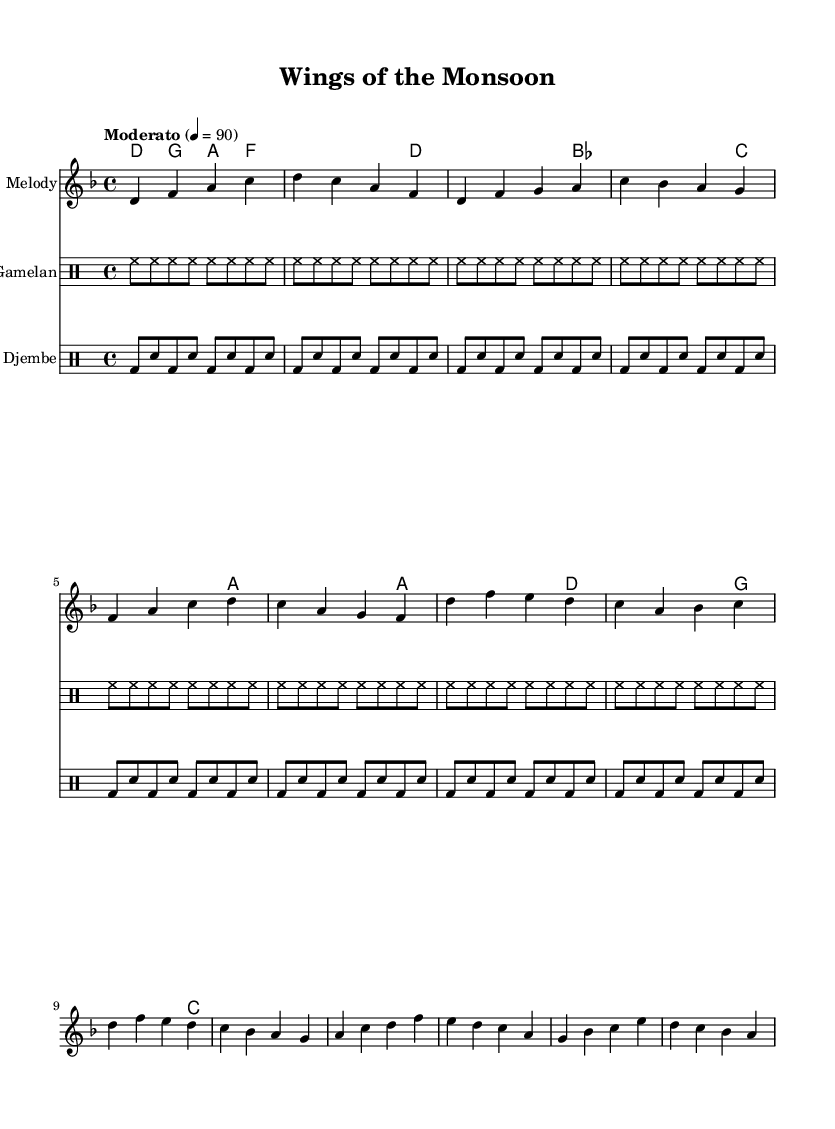What is the key signature of this music? The key signature is indicated at the beginning of the staff. It shows two flats (B♭ and E♭), which indicates the music is in D minor, as confirmed by the presence of D in the melody and harmonies.
Answer: D minor What is the time signature of this piece? The time signature is shown at the beginning of the staff and explicitly stated as 4/4. This means there are four beats in each measure and the quarter note receives one beat.
Answer: 4/4 What is the tempo marking for this piece? The tempo marking, which indicates the speed of the piece, is found above the staff. It states "Moderato" with a metronome mark of 4 = 90, suggesting a moderate pace.
Answer: Moderato What instruments are used in this music? The instruments are noted in the headers of each staff. The piece features a melody staff, a gamelan drum staff, and a djembe drum staff, representing a blend of folk and Southeast Asian influences.
Answer: Melody, Gamelan, Djembe How many measures are in the verse? To find the number of measures in the verse, we count the measures where the verse melody is indicated. The verse consists of four measures as outlined in the score.
Answer: 4 What type of rhythm pattern is used in the djembe part? The rhythm pattern for the djembe is specified in the drummode section, showing a recurring pattern of bass and snare hits. It clearly alternates between bass (bd) and snare (sn) in each measure, indicating a lively rhythmic structure characteristic of folk music.
Answer: Bass and Snare What do the gamelan instruments contribute to this composition? The gamelan part is represented with a steady hi-hat pattern (hh), which lays down a consistent rhythmic framework supporting the melody and harmonies. This contributes a unique sound texture typical of Southeast Asian music, enhancing the folk fusion aspect.
Answer: Rhythmic texture 